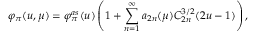Convert formula to latex. <formula><loc_0><loc_0><loc_500><loc_500>\varphi _ { \pi } ( u , \mu ) = \varphi _ { \pi } ^ { a s } ( u ) \left ( 1 + \sum _ { n = 1 } ^ { \infty } a _ { 2 n } ( \mu ) C _ { 2 n } ^ { 3 / 2 } ( 2 u - 1 ) \right ) ,</formula> 